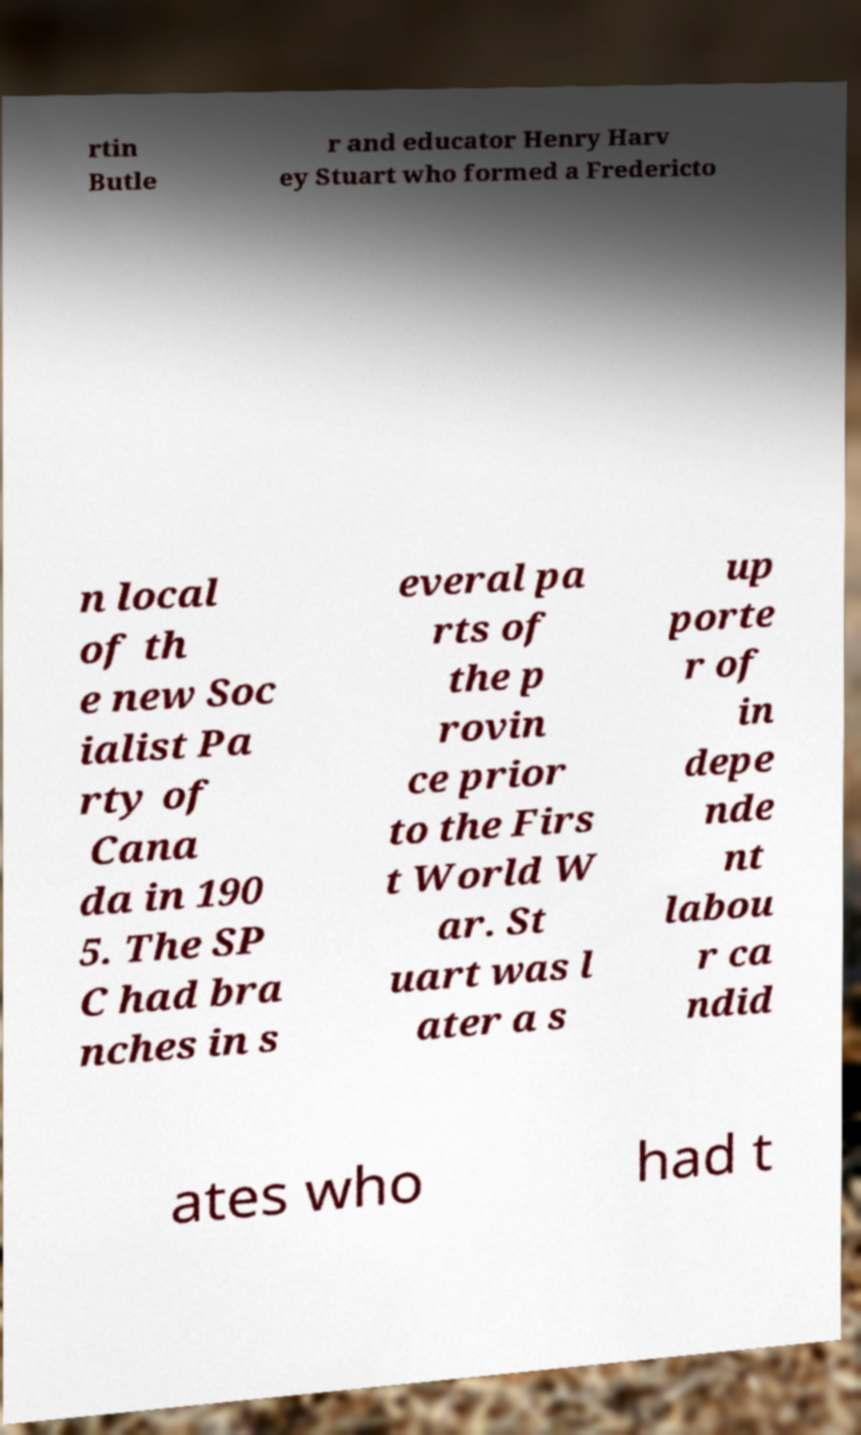Can you read and provide the text displayed in the image?This photo seems to have some interesting text. Can you extract and type it out for me? rtin Butle r and educator Henry Harv ey Stuart who formed a Fredericto n local of th e new Soc ialist Pa rty of Cana da in 190 5. The SP C had bra nches in s everal pa rts of the p rovin ce prior to the Firs t World W ar. St uart was l ater a s up porte r of in depe nde nt labou r ca ndid ates who had t 